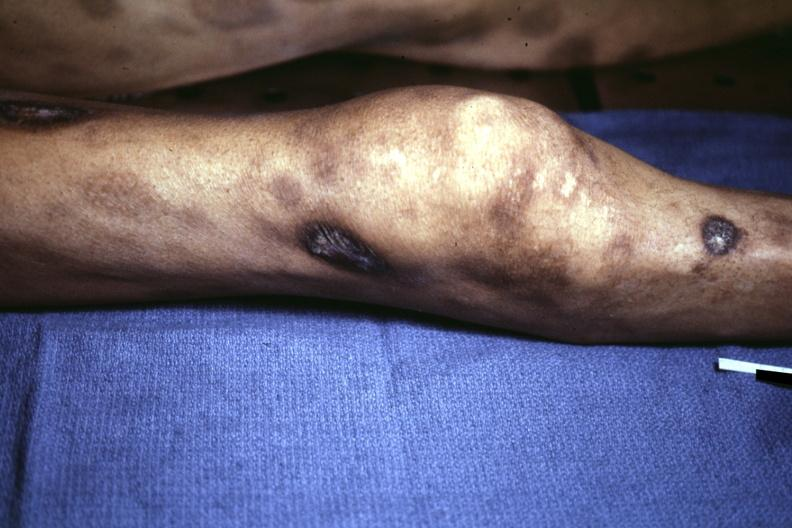what ecchymoses with necrotic and ulcerated centers looks like pyoderma gangrenosum?
Answer the question using a single word or phrase. View of knee at autopsy 